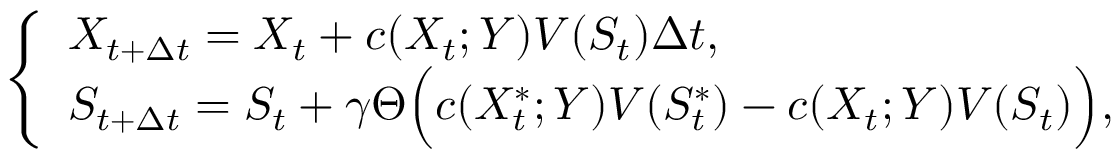Convert formula to latex. <formula><loc_0><loc_0><loc_500><loc_500>\left \{ \begin{array} { l l } { X _ { t + \Delta { t } } = X _ { t } + c ( X _ { t } ; Y ) V ( S _ { t } ) \Delta { t } , \quad } \\ { S _ { t + \Delta { t } } = S _ { t } + \gamma \Theta \left ( c ( X _ { t } ^ { \ast } ; Y ) V ( S _ { t } ^ { \ast } ) - c ( X _ { t } ; Y ) V ( S _ { t } ) \right ) , } \end{array}</formula> 